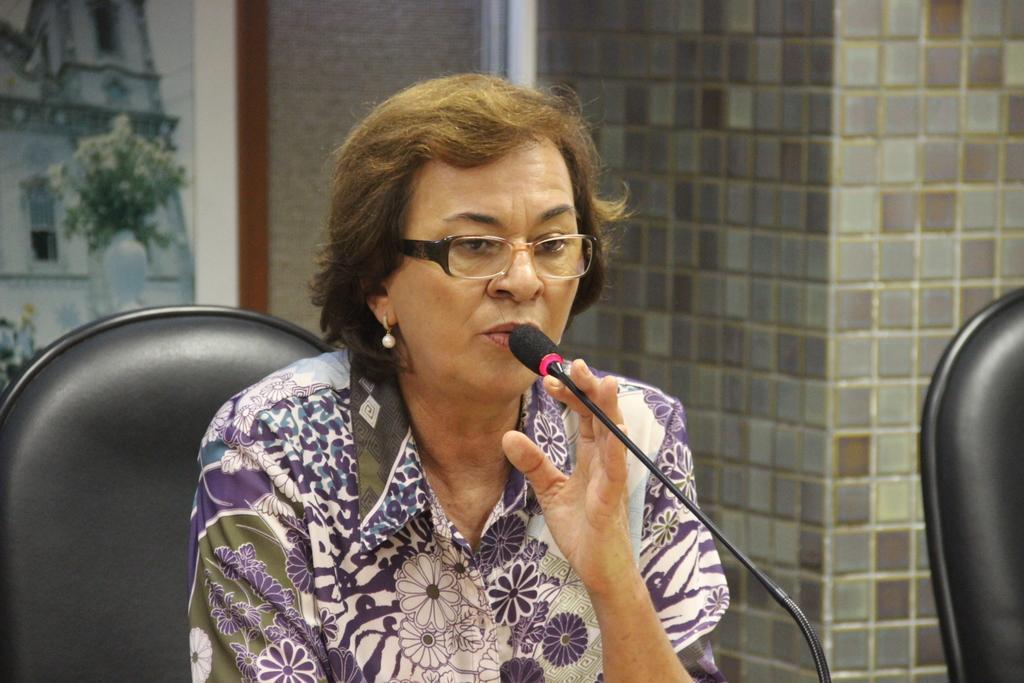Please provide a concise description of this image. In this picture there is a woman sitting on a chair and holding a microphone and talking, beside her we can see a chair. In the background of the image we can see wall and frame. 